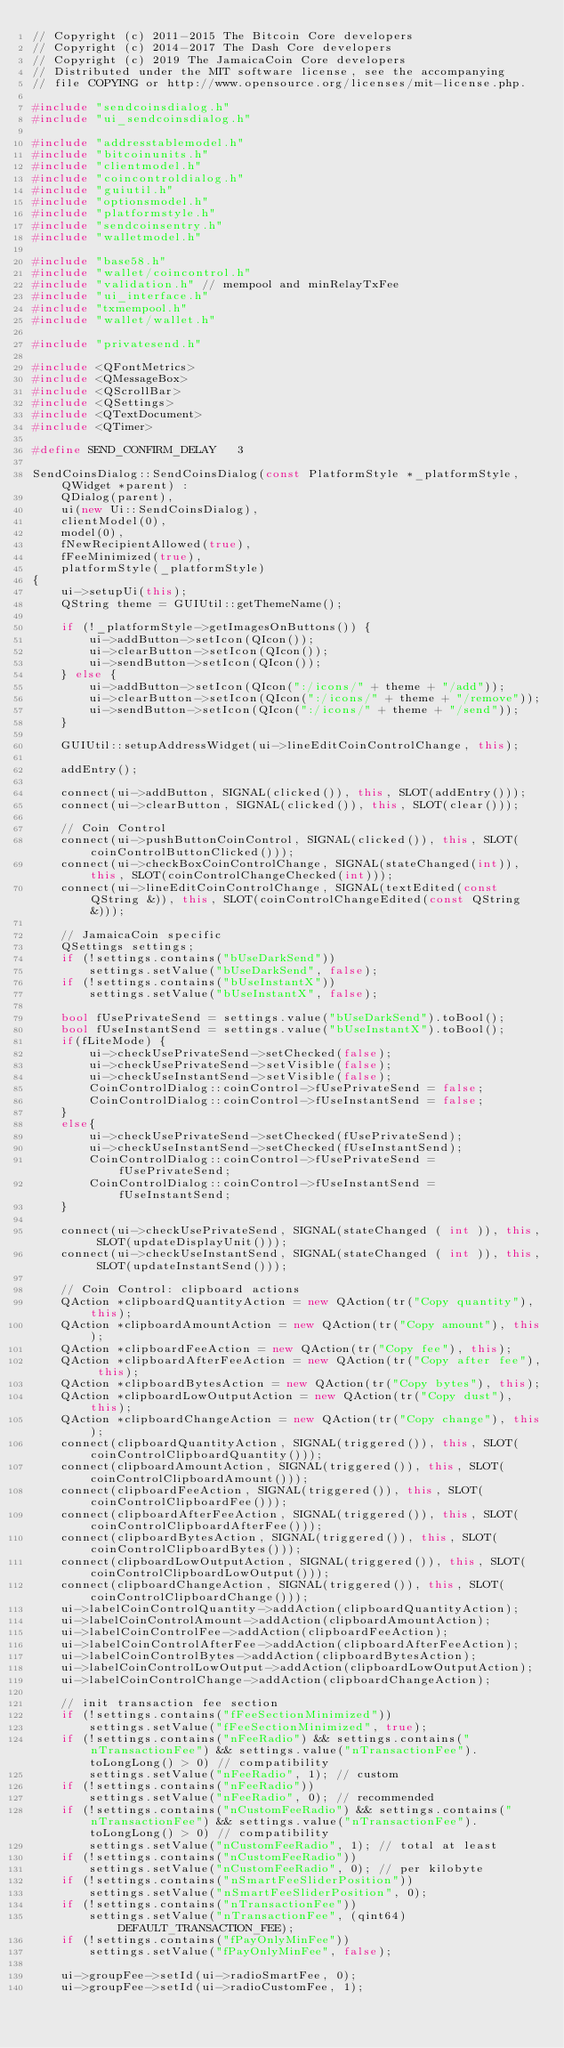<code> <loc_0><loc_0><loc_500><loc_500><_C++_>// Copyright (c) 2011-2015 The Bitcoin Core developers
// Copyright (c) 2014-2017 The Dash Core developers
// Copyright (c) 2019 The JamaicaCoin Core developers
// Distributed under the MIT software license, see the accompanying
// file COPYING or http://www.opensource.org/licenses/mit-license.php.

#include "sendcoinsdialog.h"
#include "ui_sendcoinsdialog.h"

#include "addresstablemodel.h"
#include "bitcoinunits.h"
#include "clientmodel.h"
#include "coincontroldialog.h"
#include "guiutil.h"
#include "optionsmodel.h"
#include "platformstyle.h"
#include "sendcoinsentry.h"
#include "walletmodel.h"

#include "base58.h"
#include "wallet/coincontrol.h"
#include "validation.h" // mempool and minRelayTxFee
#include "ui_interface.h"
#include "txmempool.h"
#include "wallet/wallet.h"

#include "privatesend.h"

#include <QFontMetrics>
#include <QMessageBox>
#include <QScrollBar>
#include <QSettings>
#include <QTextDocument>
#include <QTimer>

#define SEND_CONFIRM_DELAY   3

SendCoinsDialog::SendCoinsDialog(const PlatformStyle *_platformStyle, QWidget *parent) :
    QDialog(parent),
    ui(new Ui::SendCoinsDialog),
    clientModel(0),
    model(0),
    fNewRecipientAllowed(true),
    fFeeMinimized(true),
    platformStyle(_platformStyle)
{
    ui->setupUi(this);
    QString theme = GUIUtil::getThemeName();

    if (!_platformStyle->getImagesOnButtons()) {
        ui->addButton->setIcon(QIcon());
        ui->clearButton->setIcon(QIcon());
        ui->sendButton->setIcon(QIcon());
    } else {
        ui->addButton->setIcon(QIcon(":/icons/" + theme + "/add"));
        ui->clearButton->setIcon(QIcon(":/icons/" + theme + "/remove"));
        ui->sendButton->setIcon(QIcon(":/icons/" + theme + "/send"));
    }

    GUIUtil::setupAddressWidget(ui->lineEditCoinControlChange, this);

    addEntry();

    connect(ui->addButton, SIGNAL(clicked()), this, SLOT(addEntry()));
    connect(ui->clearButton, SIGNAL(clicked()), this, SLOT(clear()));

    // Coin Control
    connect(ui->pushButtonCoinControl, SIGNAL(clicked()), this, SLOT(coinControlButtonClicked()));
    connect(ui->checkBoxCoinControlChange, SIGNAL(stateChanged(int)), this, SLOT(coinControlChangeChecked(int)));
    connect(ui->lineEditCoinControlChange, SIGNAL(textEdited(const QString &)), this, SLOT(coinControlChangeEdited(const QString &)));

    // JamaicaCoin specific
    QSettings settings;
    if (!settings.contains("bUseDarkSend"))
        settings.setValue("bUseDarkSend", false);
    if (!settings.contains("bUseInstantX"))
        settings.setValue("bUseInstantX", false);

    bool fUsePrivateSend = settings.value("bUseDarkSend").toBool();
    bool fUseInstantSend = settings.value("bUseInstantX").toBool();
    if(fLiteMode) {
        ui->checkUsePrivateSend->setChecked(false);
        ui->checkUsePrivateSend->setVisible(false);
        ui->checkUseInstantSend->setVisible(false);
        CoinControlDialog::coinControl->fUsePrivateSend = false;
        CoinControlDialog::coinControl->fUseInstantSend = false;
    }
    else{
        ui->checkUsePrivateSend->setChecked(fUsePrivateSend);
        ui->checkUseInstantSend->setChecked(fUseInstantSend);
        CoinControlDialog::coinControl->fUsePrivateSend = fUsePrivateSend;
        CoinControlDialog::coinControl->fUseInstantSend = fUseInstantSend;
    }

    connect(ui->checkUsePrivateSend, SIGNAL(stateChanged ( int )), this, SLOT(updateDisplayUnit()));
    connect(ui->checkUseInstantSend, SIGNAL(stateChanged ( int )), this, SLOT(updateInstantSend()));

    // Coin Control: clipboard actions
    QAction *clipboardQuantityAction = new QAction(tr("Copy quantity"), this);
    QAction *clipboardAmountAction = new QAction(tr("Copy amount"), this);
    QAction *clipboardFeeAction = new QAction(tr("Copy fee"), this);
    QAction *clipboardAfterFeeAction = new QAction(tr("Copy after fee"), this);
    QAction *clipboardBytesAction = new QAction(tr("Copy bytes"), this);
    QAction *clipboardLowOutputAction = new QAction(tr("Copy dust"), this);
    QAction *clipboardChangeAction = new QAction(tr("Copy change"), this);
    connect(clipboardQuantityAction, SIGNAL(triggered()), this, SLOT(coinControlClipboardQuantity()));
    connect(clipboardAmountAction, SIGNAL(triggered()), this, SLOT(coinControlClipboardAmount()));
    connect(clipboardFeeAction, SIGNAL(triggered()), this, SLOT(coinControlClipboardFee()));
    connect(clipboardAfterFeeAction, SIGNAL(triggered()), this, SLOT(coinControlClipboardAfterFee()));
    connect(clipboardBytesAction, SIGNAL(triggered()), this, SLOT(coinControlClipboardBytes()));
    connect(clipboardLowOutputAction, SIGNAL(triggered()), this, SLOT(coinControlClipboardLowOutput()));
    connect(clipboardChangeAction, SIGNAL(triggered()), this, SLOT(coinControlClipboardChange()));
    ui->labelCoinControlQuantity->addAction(clipboardQuantityAction);
    ui->labelCoinControlAmount->addAction(clipboardAmountAction);
    ui->labelCoinControlFee->addAction(clipboardFeeAction);
    ui->labelCoinControlAfterFee->addAction(clipboardAfterFeeAction);
    ui->labelCoinControlBytes->addAction(clipboardBytesAction);
    ui->labelCoinControlLowOutput->addAction(clipboardLowOutputAction);
    ui->labelCoinControlChange->addAction(clipboardChangeAction);

    // init transaction fee section
    if (!settings.contains("fFeeSectionMinimized"))
        settings.setValue("fFeeSectionMinimized", true);
    if (!settings.contains("nFeeRadio") && settings.contains("nTransactionFee") && settings.value("nTransactionFee").toLongLong() > 0) // compatibility
        settings.setValue("nFeeRadio", 1); // custom
    if (!settings.contains("nFeeRadio"))
        settings.setValue("nFeeRadio", 0); // recommended
    if (!settings.contains("nCustomFeeRadio") && settings.contains("nTransactionFee") && settings.value("nTransactionFee").toLongLong() > 0) // compatibility
        settings.setValue("nCustomFeeRadio", 1); // total at least
    if (!settings.contains("nCustomFeeRadio"))
        settings.setValue("nCustomFeeRadio", 0); // per kilobyte
    if (!settings.contains("nSmartFeeSliderPosition"))
        settings.setValue("nSmartFeeSliderPosition", 0);
    if (!settings.contains("nTransactionFee"))
        settings.setValue("nTransactionFee", (qint64)DEFAULT_TRANSACTION_FEE);
    if (!settings.contains("fPayOnlyMinFee"))
        settings.setValue("fPayOnlyMinFee", false);

    ui->groupFee->setId(ui->radioSmartFee, 0);
    ui->groupFee->setId(ui->radioCustomFee, 1);</code> 